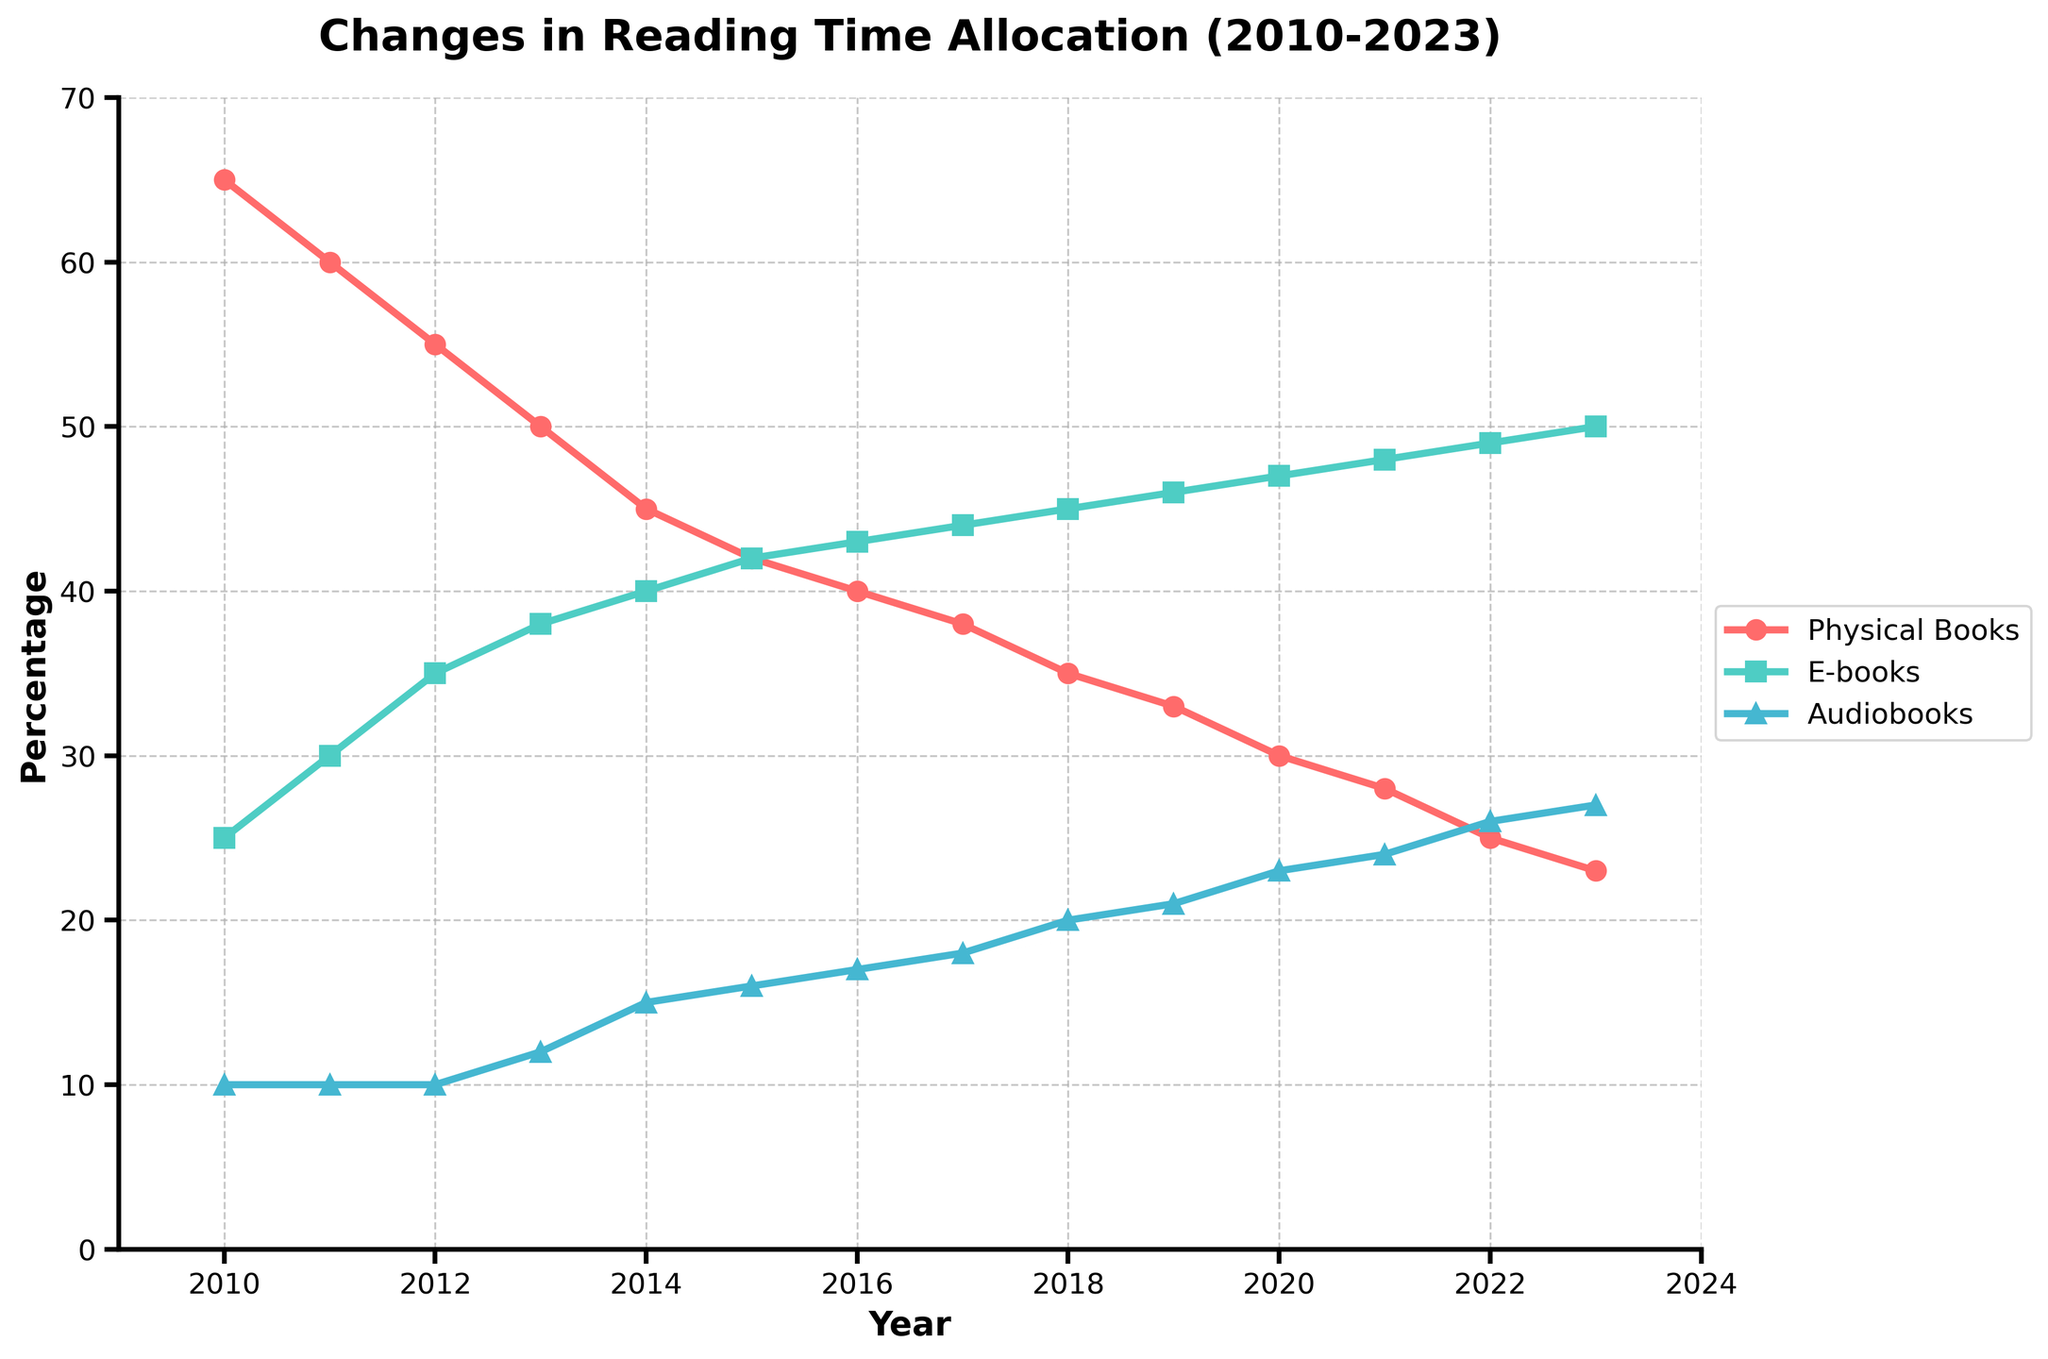What percentage of reading time was allocated to physical books in 2015 compared to e-books in the same year? In 2015, the plot shows that 42% of reading time was allocated to physical books. The allocation for e-books in the same year was also 42%. Thus, the percentage allocation was the same for both.
Answer: 42% and 42% Between which consecutive years did audiobooks see the highest increase in reading time allocation? By analyzing the incremental changes in the audiobooks line, we can identify that the largest jump occurs between 2012 and 2013, where the percentage increased from 10% to 12%.
Answer: 2012 to 2013 By how much did the reading time allocation for physical books decrease from 2010 to 2023? The plot shows that physical books' allocation dropped from 65% in 2010 to 23% in 2023. The decrease is calculated as 65% - 23% = 42%.
Answer: 42% What is the average reading time allocation for audiobooks from 2010 to 2023? Adding all the percentages of audiobooks from 2010 to 2023 gives 10 + 10 + 10 + 12 + 15 + 16 + 17 + 18 + 20 + 21 + 23 + 24 + 26 + 27 = 249. Dividing this by the number of years (14), the average is 249 / 14 = 17.79%.
Answer: 17.79% Which type of books had the highest increase in reading time allocation between 2010 and 2023? The plot indicates that e-books increased from 25% in 2010 to 50% in 2023. The increase is 50% - 25% = 25%. Physical books and audiobooks did not increase by this much.
Answer: E-books What year did the percentage of reading time for e-books surpass that of physical books? By examining the crossover points in the plots, we see that in 2014, e-books reached 40% while physical books fell to 45%. By 2015, e-books hit 42% and physical books also hit 42%, signaling the point of surpassing.
Answer: 2015 What is the difference in the percentage of reading time allocation for e-books and physical books in 2023? In 2023, the plot shows the allocation for e-books is 50% and for physical books is 23%. The difference is 50% - 23% = 27%.
Answer: 27% By how much did the allocation for audiobooks increase from 2010 to 2020? The plot shows that audiobooks' allocation went from 10% in 2010 to 23% in 2020. The increase is 23% - 10% = 13%.
Answer: 13% Which year did audiobooks' reading time allocation reach 20%? Observing the plot, we see that 20% allocation for audiobooks occurs in the year 2018.
Answer: 2018 What is the sum of the percentage reading time for physical books and audiobooks in 2021? In 2021, the allocation for physical books is 28% and for audiobooks is 24%. The sum is 28% + 24% = 52%.
Answer: 52% 